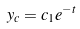<formula> <loc_0><loc_0><loc_500><loc_500>y _ { c } = c _ { 1 } e ^ { - t }</formula> 